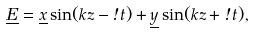Convert formula to latex. <formula><loc_0><loc_0><loc_500><loc_500>\underline { E } = \underline { x } \sin ( k z - \omega t ) + \underline { y } \sin ( k z + \omega t ) ,</formula> 